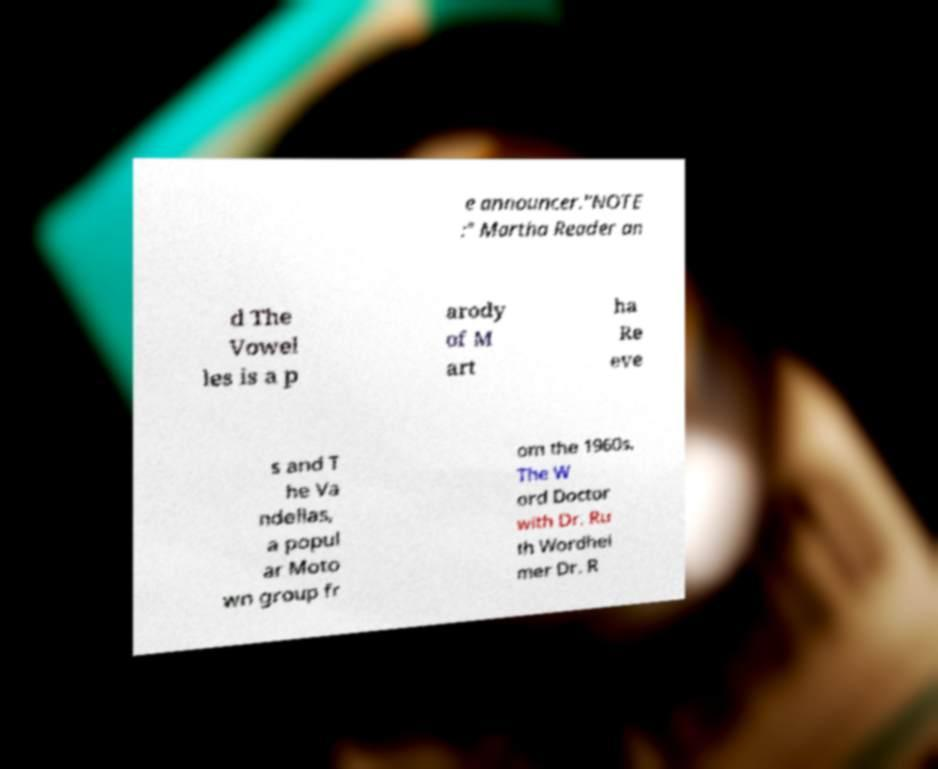There's text embedded in this image that I need extracted. Can you transcribe it verbatim? e announcer."NOTE :" Martha Reader an d The Vowel les is a p arody of M art ha Re eve s and T he Va ndellas, a popul ar Moto wn group fr om the 1960s. The W ord Doctor with Dr. Ru th Wordhei mer Dr. R 